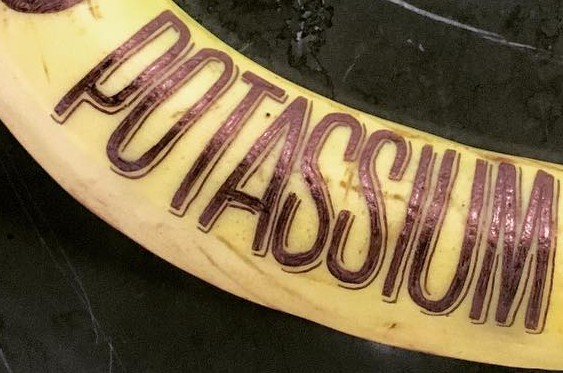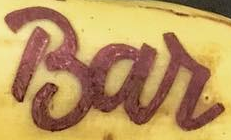Read the text content from these images in order, separated by a semicolon. POTASSIUM; Bar 